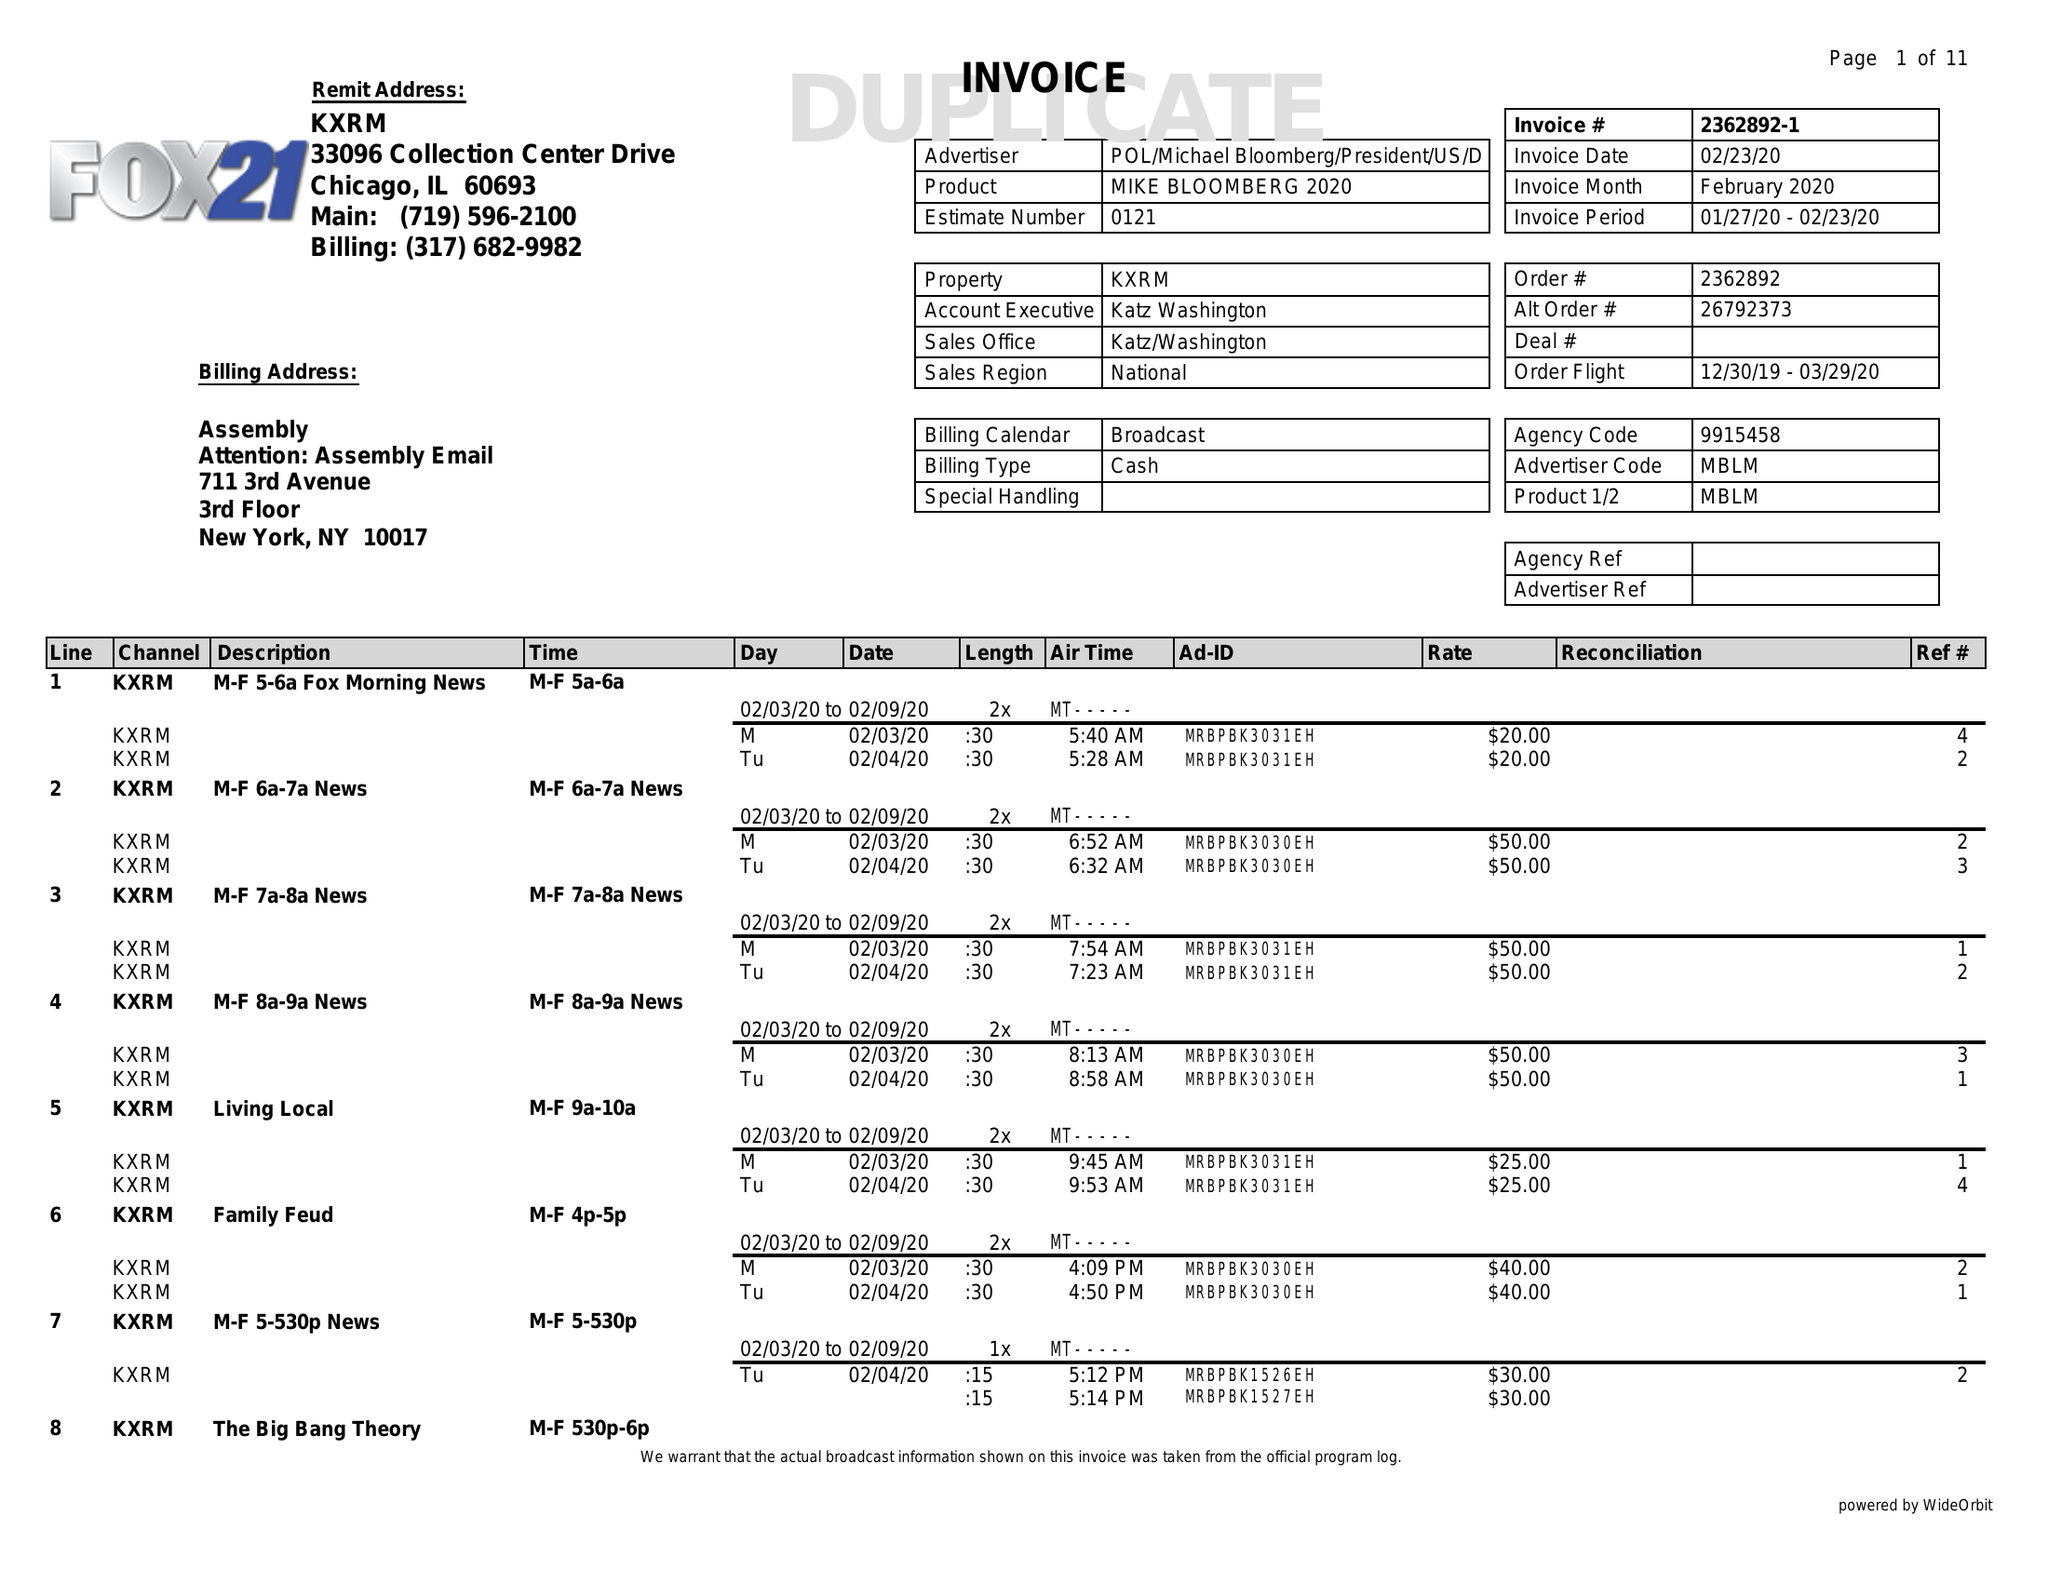What is the value for the advertiser?
Answer the question using a single word or phrase. POL/MICHAELBLOOMBERG/PRESIDENT/US/DEM 